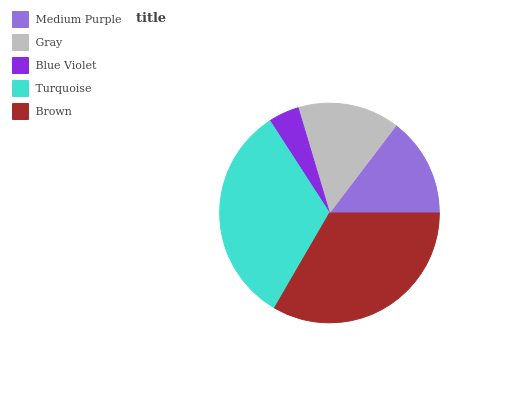Is Blue Violet the minimum?
Answer yes or no. Yes. Is Brown the maximum?
Answer yes or no. Yes. Is Gray the minimum?
Answer yes or no. No. Is Gray the maximum?
Answer yes or no. No. Is Gray greater than Medium Purple?
Answer yes or no. Yes. Is Medium Purple less than Gray?
Answer yes or no. Yes. Is Medium Purple greater than Gray?
Answer yes or no. No. Is Gray less than Medium Purple?
Answer yes or no. No. Is Gray the high median?
Answer yes or no. Yes. Is Gray the low median?
Answer yes or no. Yes. Is Blue Violet the high median?
Answer yes or no. No. Is Brown the low median?
Answer yes or no. No. 